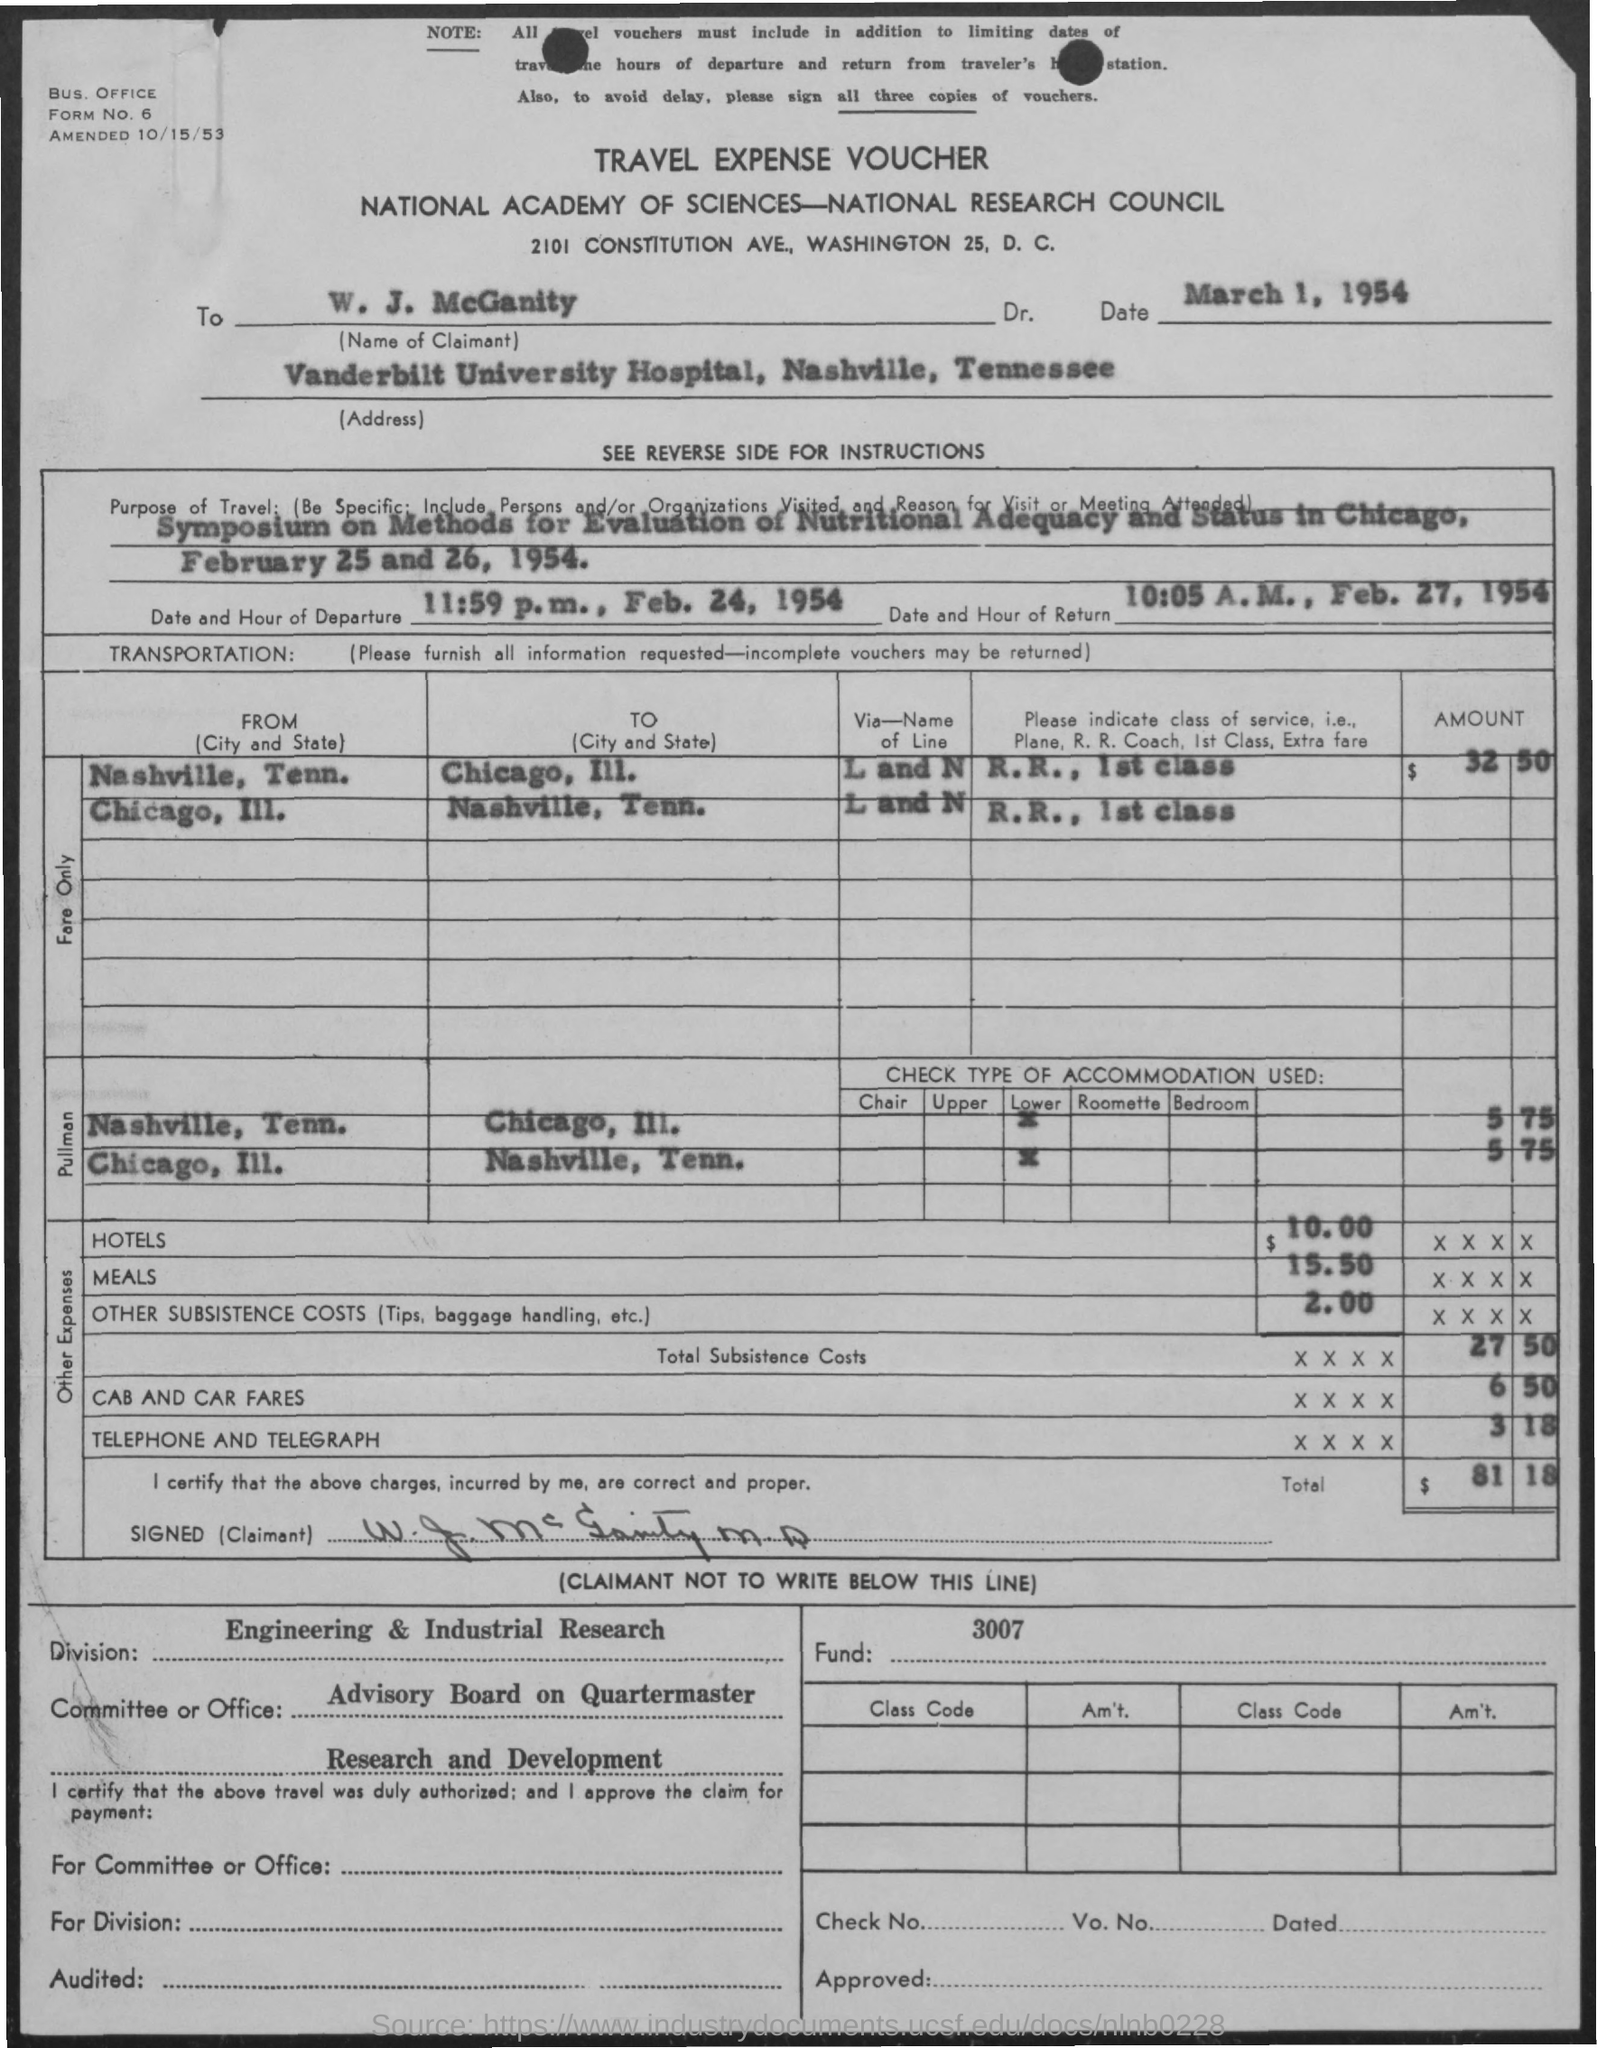What voucher is it?
Your answer should be very brief. Travel expense voucher. What is the name of claimant?
Keep it short and to the point. W. j. mcganity. What is the address of the claimant?
Your answer should be very brief. Vanderbilt University Hospital, Nashville, Tennessee. What is the date and hour of departure?
Your response must be concise. 11:59 p.m., Feb. 24, 1954. What is the voucher date?
Give a very brief answer. March 1, 1954. How much is the hotel cost?
Your response must be concise. $ 10.00. How much is the total cost?
Provide a succinct answer. $81.18. 